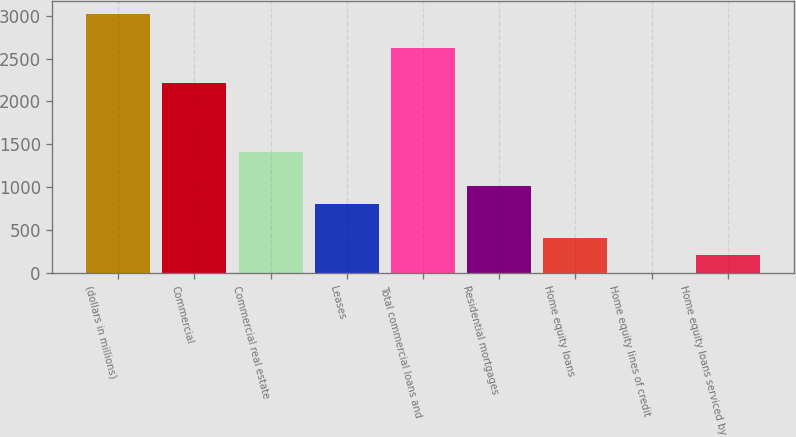<chart> <loc_0><loc_0><loc_500><loc_500><bar_chart><fcel>(dollars in millions)<fcel>Commercial<fcel>Commercial real estate<fcel>Leases<fcel>Total commercial loans and<fcel>Residential mortgages<fcel>Home equity loans<fcel>Home equity lines of credit<fcel>Home equity loans serviced by<nl><fcel>3023.5<fcel>2218.3<fcel>1413.1<fcel>809.2<fcel>2620.9<fcel>1010.5<fcel>406.6<fcel>4<fcel>205.3<nl></chart> 